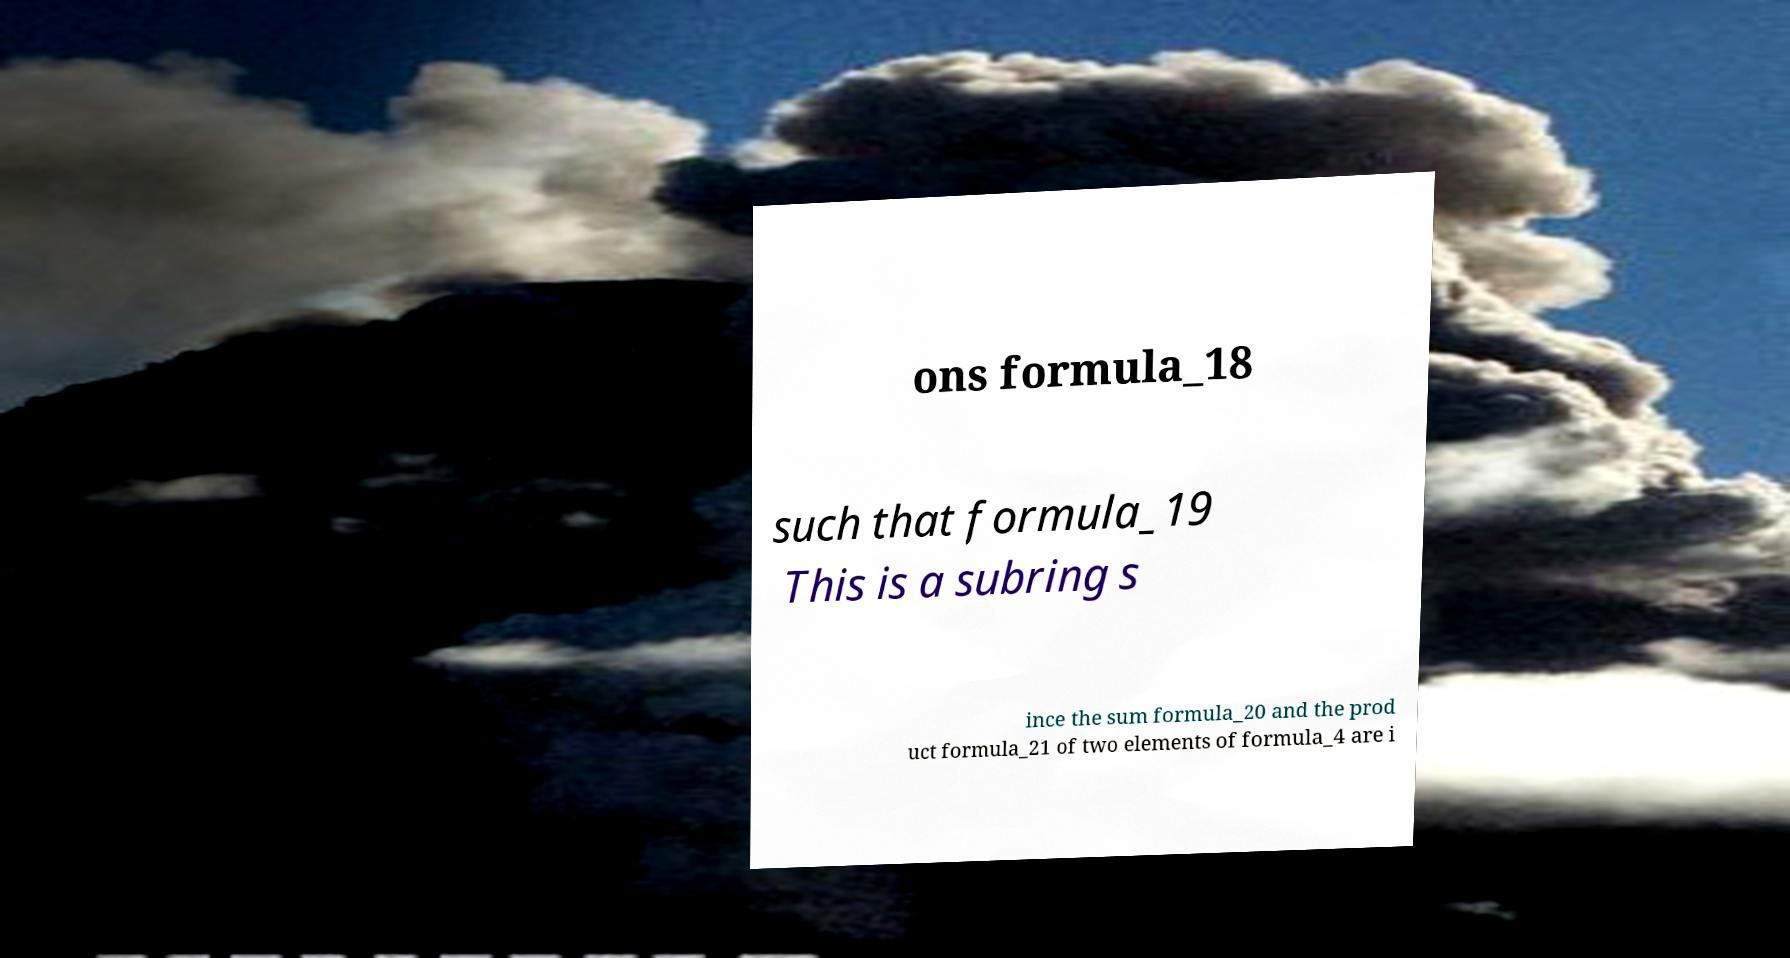Please read and relay the text visible in this image. What does it say? ons formula_18 such that formula_19 This is a subring s ince the sum formula_20 and the prod uct formula_21 of two elements of formula_4 are i 